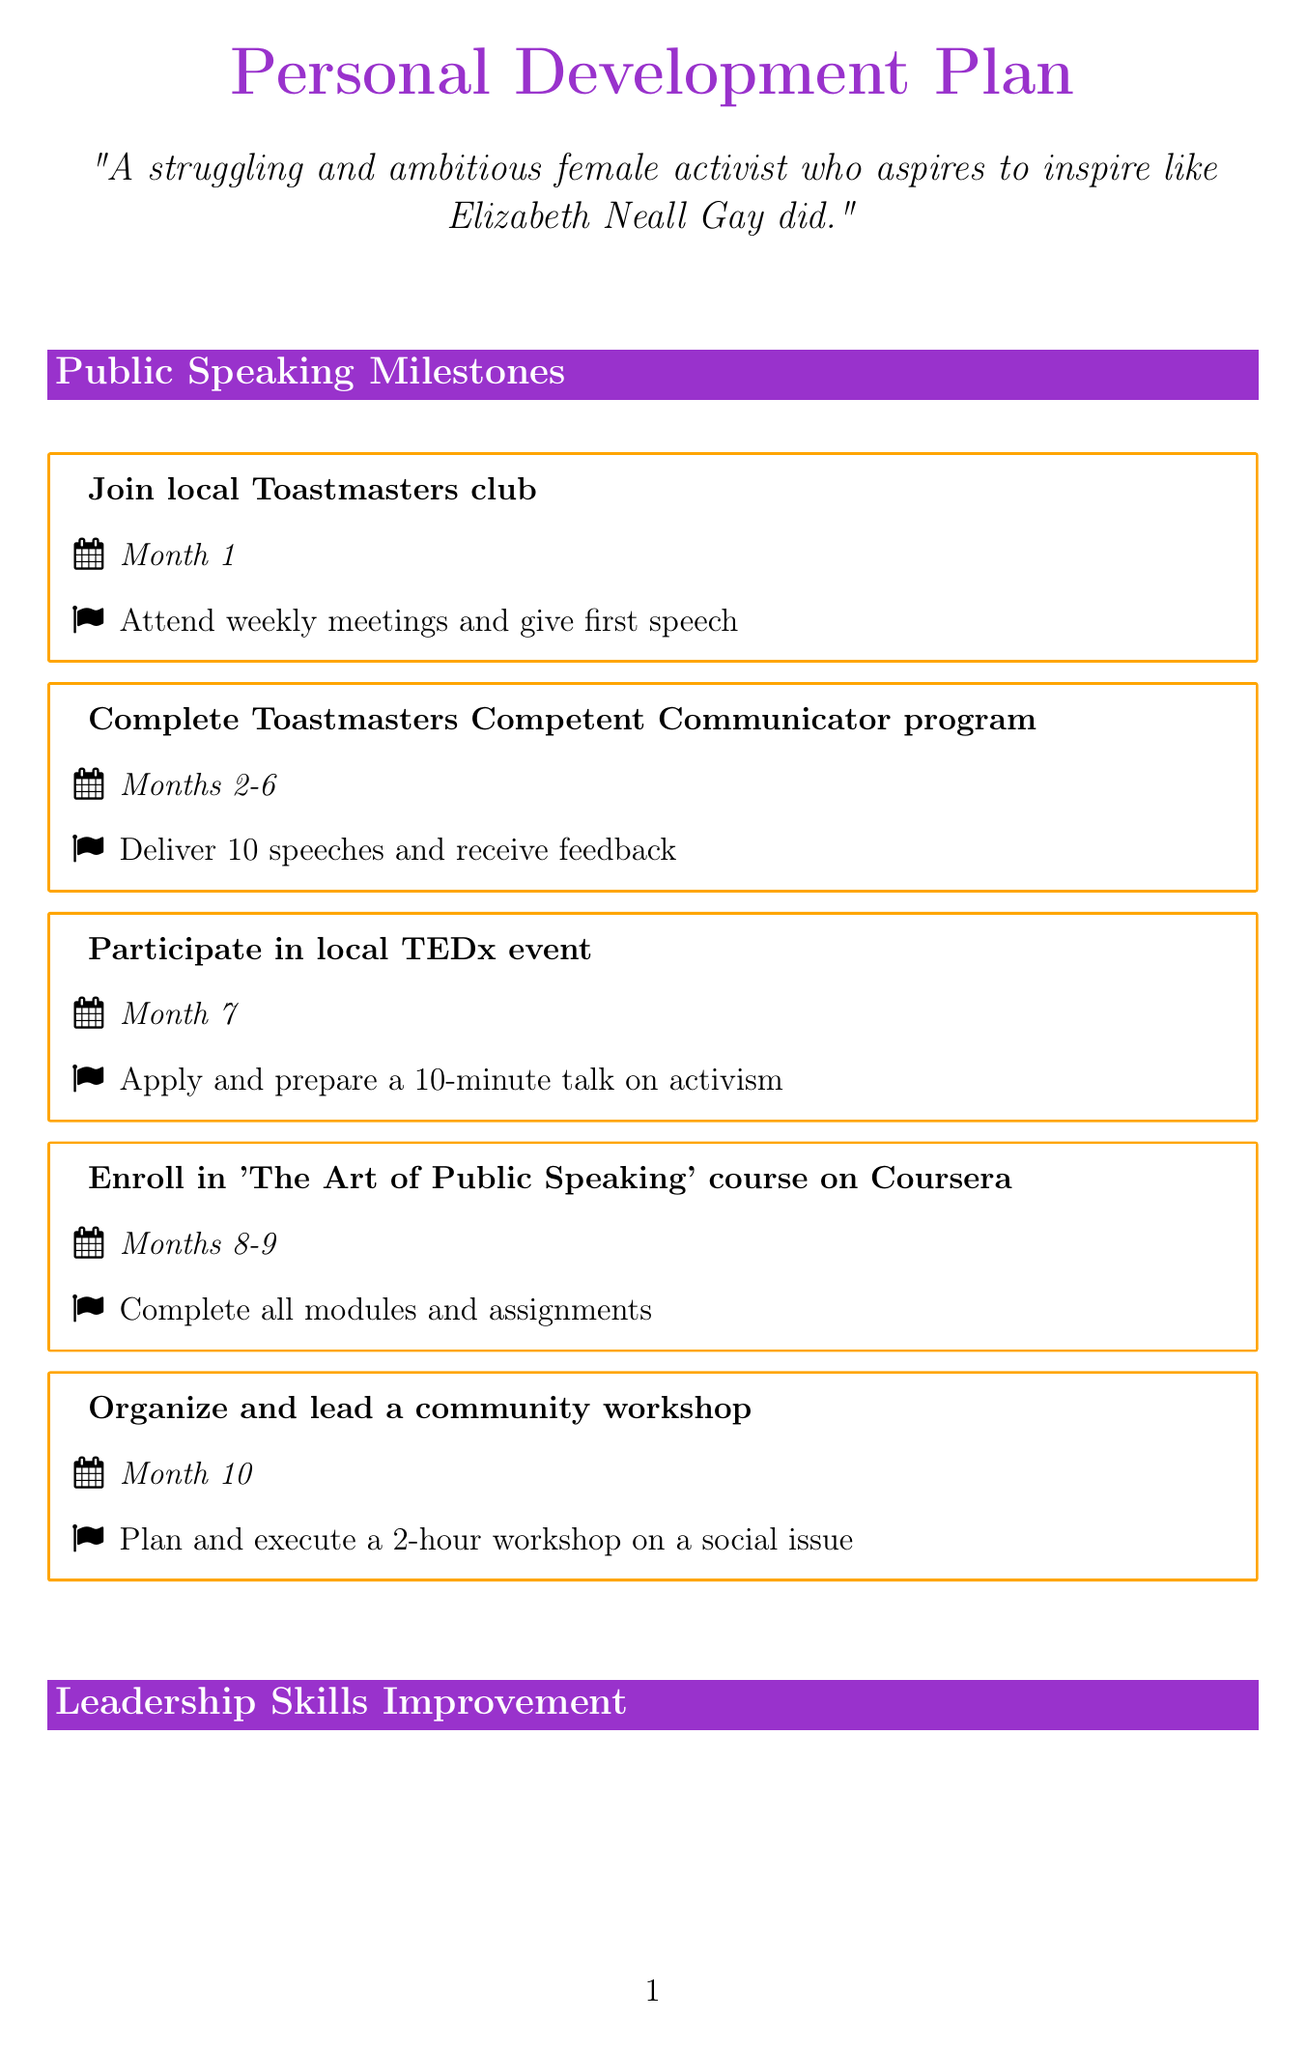What is the first milestone in public speaking? The first milestone in public speaking is "Join local Toastmasters club."
Answer: Join local Toastmasters club How long is the timeframe for completing the Toastmasters Competent Communicator program? The timeframe for completing the program is specified as "Months 2-6."
Answer: Months 2-6 What is the goal of participating in the local TEDx event? The goal is to "Apply and prepare a 10-minute talk on activism."
Answer: Apply and prepare a 10-minute talk on activism How many speeches must be delivered for the Toastmasters program? The requirement is to deliver "10 speeches."
Answer: 10 speeches What is a key activity for months 9-12? The key activity is to "Participate in 'Women's March' organization committee."
Answer: Participate in 'Women's March' organization committee What book should be read in the fourth month? The book to read is "Leaders Eat Last."
Answer: Leaders Eat Last How often should the blog be created? The frequency is indicated as "Monthly."
Answer: Monthly What is the total duration for the leadership role volunteering? The total duration is specified as "Months 1-3."
Answer: Months 1-3 What is the goal of studying Elizabeth Neall Gay's activism techniques? The goal is to "Apply historical activist strategies to modern issues."
Answer: Apply historical activist strategies to modern issues Which course is to be completed in months 6-7? The course to be completed is "'Becoming a Transformational Leader' course on edX."
Answer: 'Becoming a Transformational Leader' course on edX 